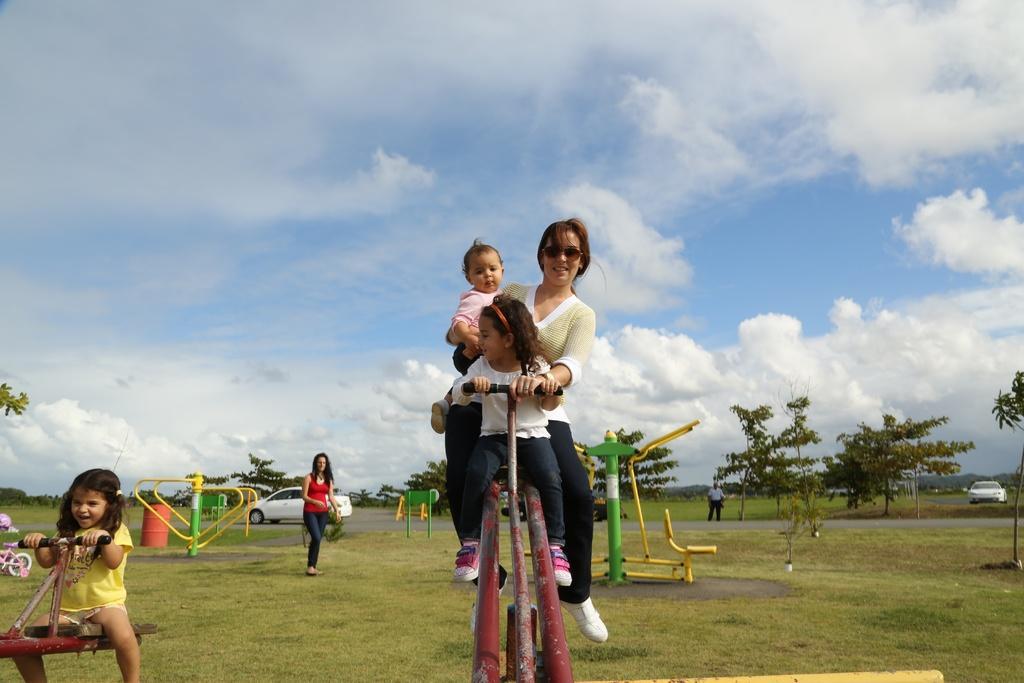Please provide a concise description of this image. In this image I can see the group of people and I can see few metal objects in the park. In the background I can see many trees, clouds and the sky. 